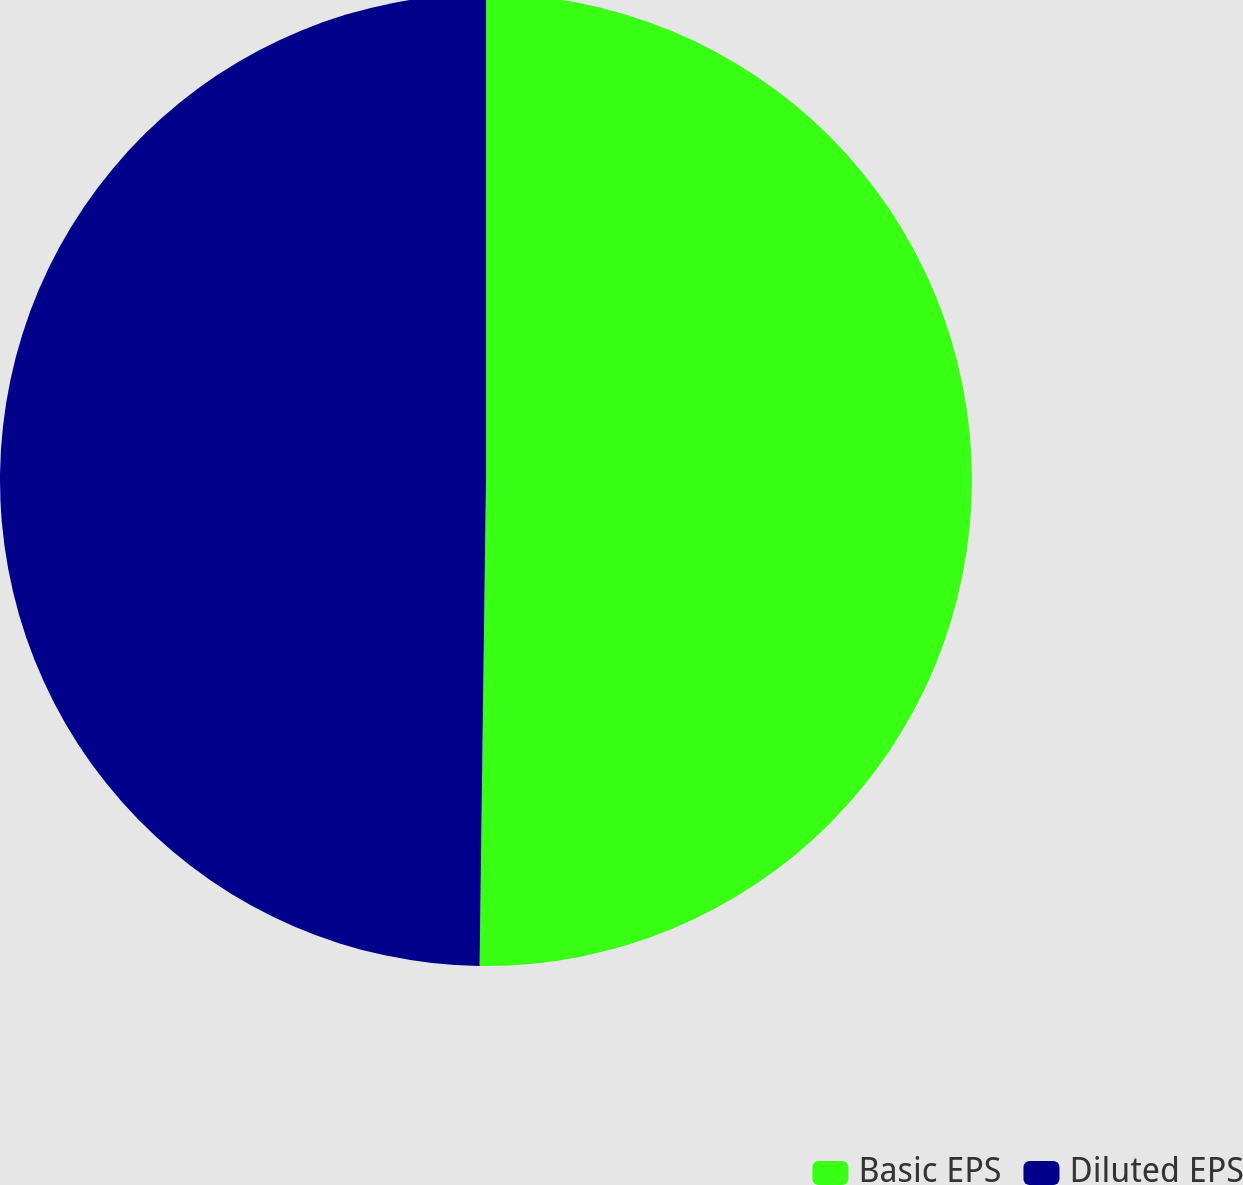Convert chart to OTSL. <chart><loc_0><loc_0><loc_500><loc_500><pie_chart><fcel>Basic EPS<fcel>Diluted EPS<nl><fcel>50.21%<fcel>49.79%<nl></chart> 